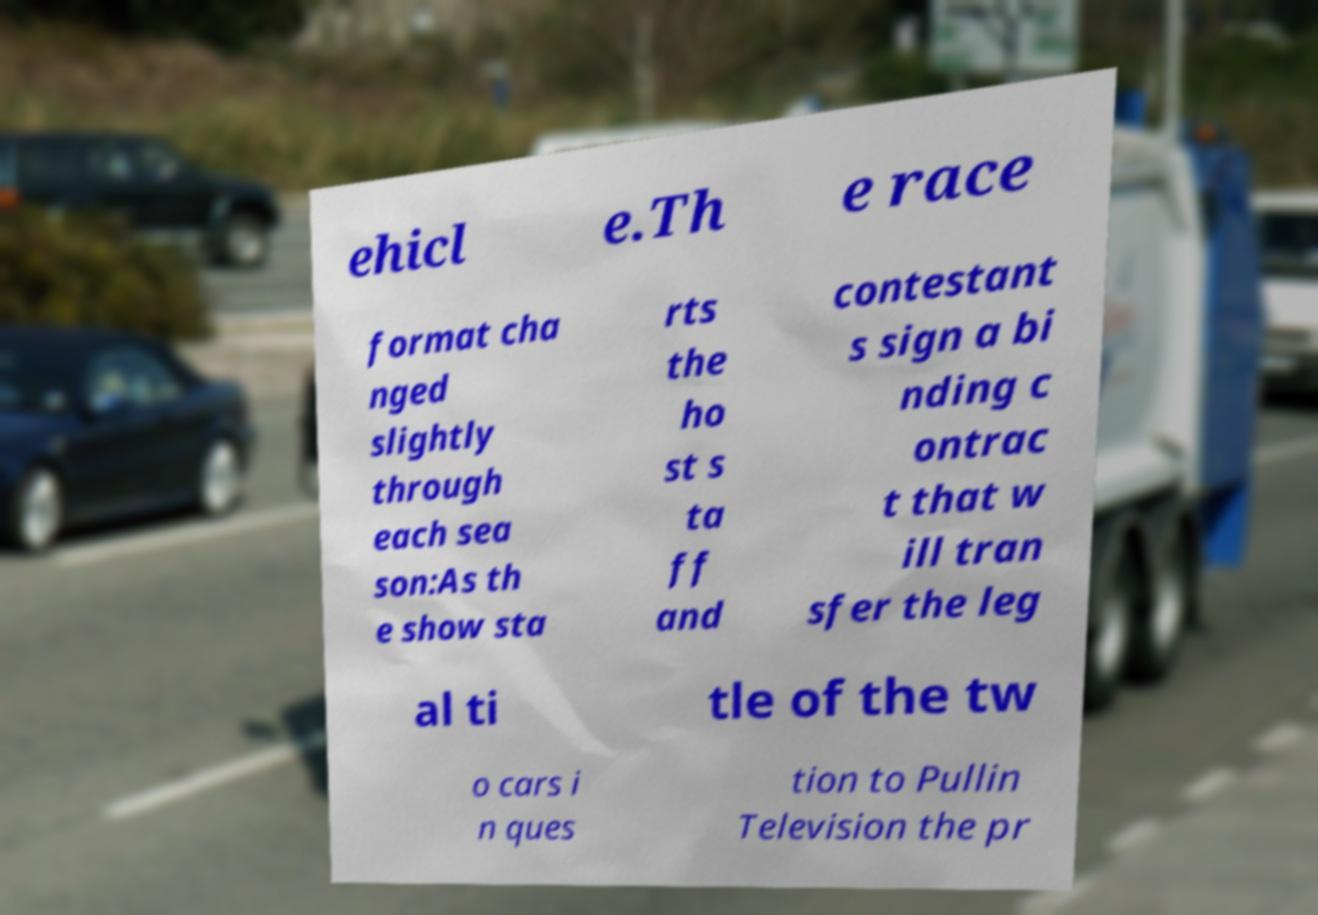Please read and relay the text visible in this image. What does it say? ehicl e.Th e race format cha nged slightly through each sea son:As th e show sta rts the ho st s ta ff and contestant s sign a bi nding c ontrac t that w ill tran sfer the leg al ti tle of the tw o cars i n ques tion to Pullin Television the pr 